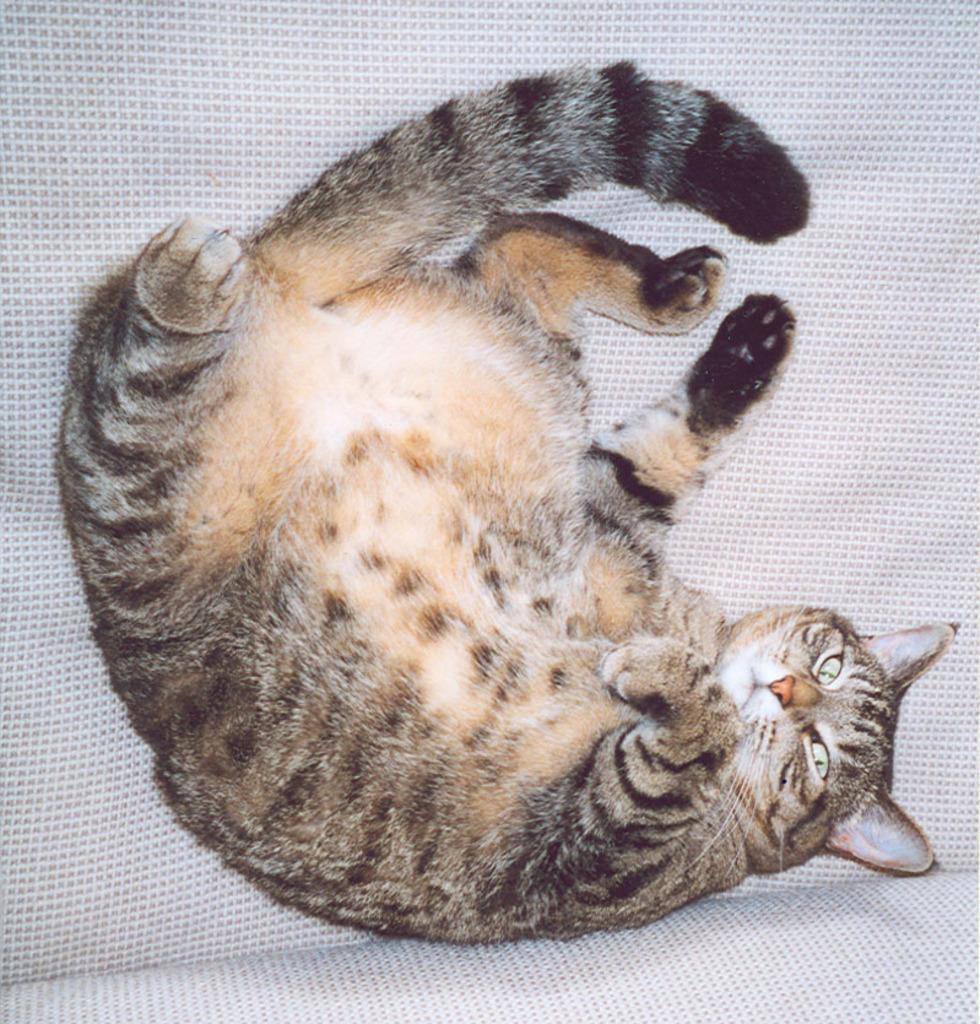What animal is present in the image? There is a cat in the picture. What is the cat lying on? The cat is lying on a white surface. What type of pan is being used by the cat's owner in the image? There is no pan or owner present in the image; it only features a cat lying on a white surface. 